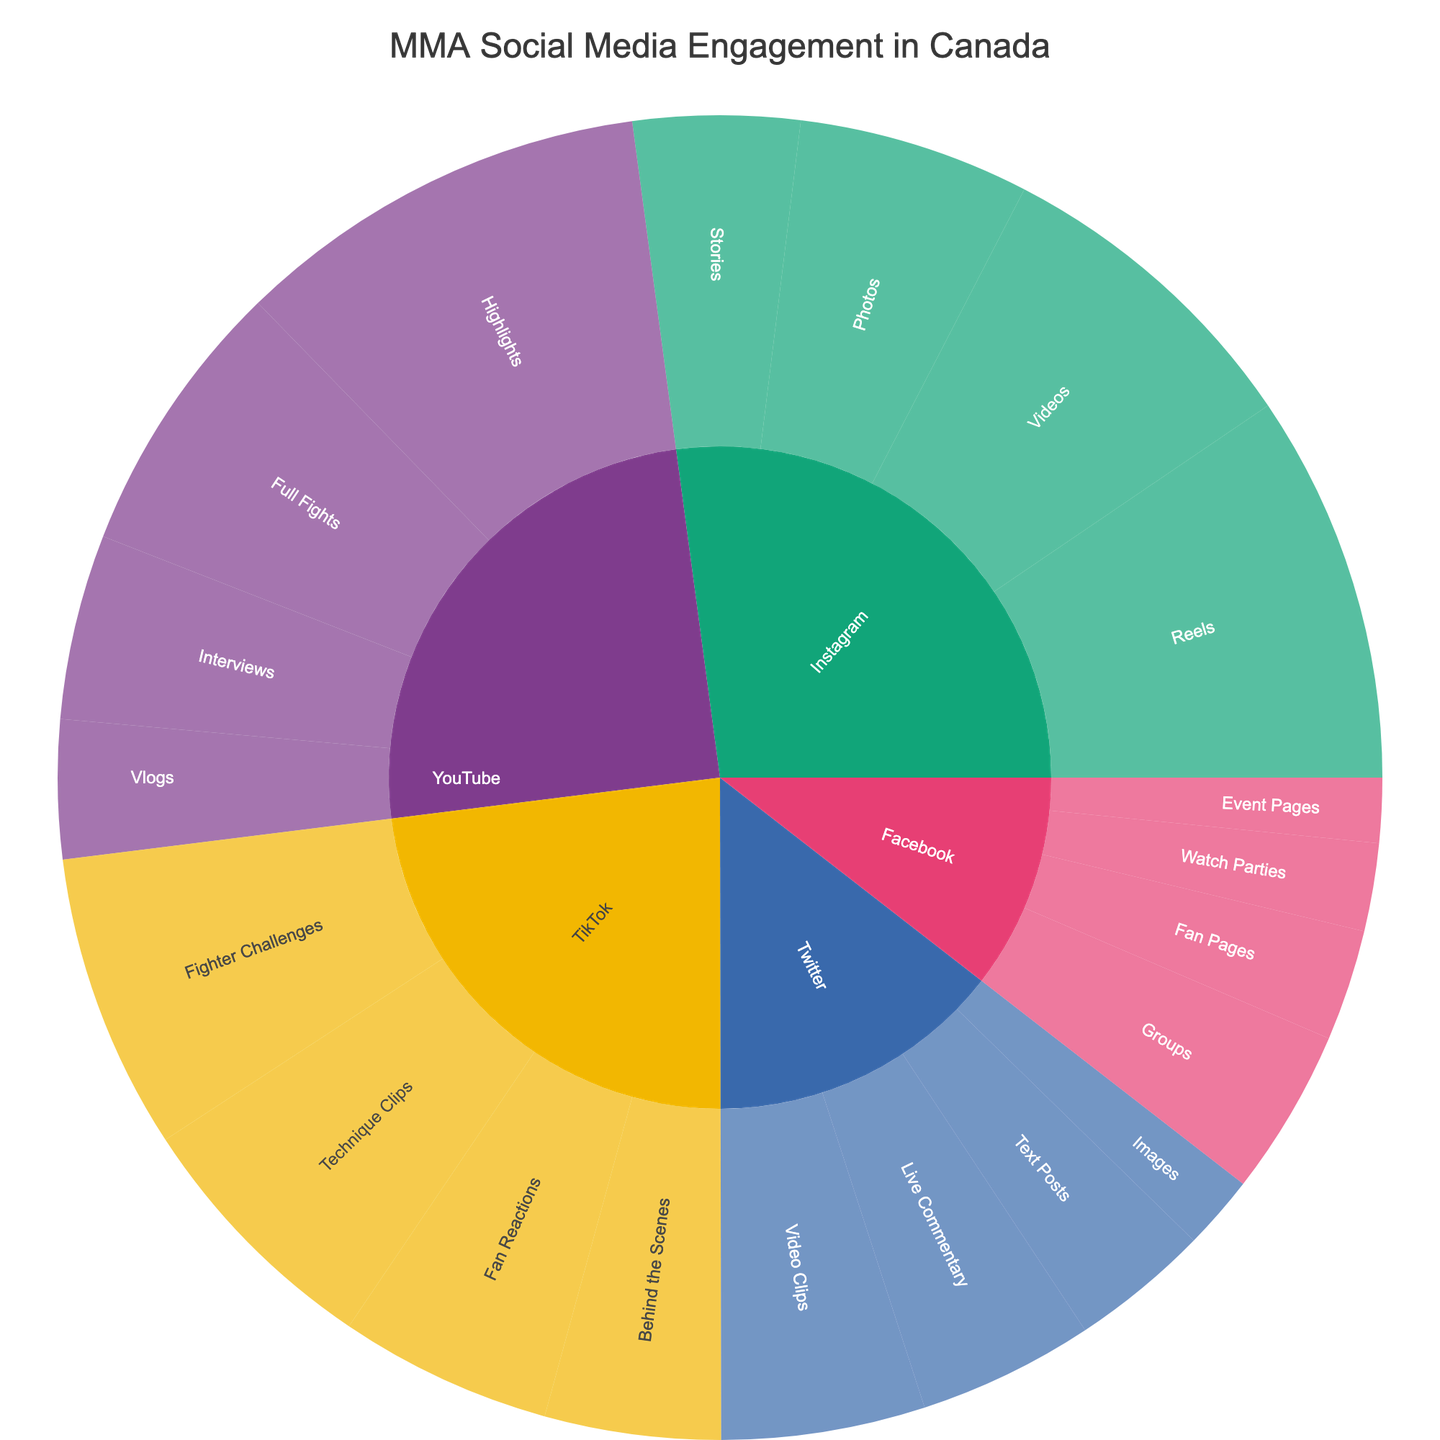What platform generates the most engagement? By looking at the Sunburst Plot, we observe the largest section out of all the platforms. Instagram shows the highest engagement with larger subdivisions when aggregated.
Answer: Instagram What type of content on YouTube has the highest engagement? By examining the YouTube slice within the plot, we see the largest single segment labeled as "Highlights". This signifies the highest engagement.
Answer: Highlights Compare the engagement of Instagram Stories to Twitter Video Clips. Which has more, and by how much? From the plot, Instagram Stories have 180,000 engagements and Twitter Video Clips have 220,000 engagements. Subtracting these values gives 220,000 - 180,000.
Answer: Twitter Video Clips by 40,000 What’s the total engagement for all TikTok content combined? TikTok has segments for Technique Clips (280,000), Fighter Challenges (320,000), Behind the Scenes (190,000), and Fan Reactions (230,000). Summing these: 280,000 + 320,000 + 190,000 + 230,000 equals 1,020,000.
Answer: 1,020,000 Which type of content is unique to Facebook in this dataset, and what’s its engagement? Inspecting the Facebook section, "Watch Parties" is unique, and its engagement is labeled as 95,000.
Answer: Watch Parties (95,000) Is the engagement for YouTube Interviews higher or lower than YouTube Vlogs? By how much? For YouTube, Interviews show 200,000 engagements while Vlogs show 150,000. The difference is 200,000 - 150,000.
Answer: Higher by 50,000 How does the engagement for Instagram Reels compare to YouTube Highlights? Instagram Reels have 420,000 engagements while YouTube Highlights have 450,000. Comparing these, YouTube Highlights are greater by 450,000 - 420,000.
Answer: YouTube Highlights by 30,000 Does Twitter Live Commentary have higher or lower engagement than Facebook Fan Pages? Twitter Live Commentary has an engagement of 190,000 and Facebook Fan Pages have 120,000. Comparing them, Live Commentary is higher.
Answer: Higher What is the average engagement for all Facebook content? Facebook has Fan Pages (120,000), Event Pages (70,000), Watch Parties (95,000), and Groups (180,000). Summing these up: 120,000 + 70,000 + 95,000 + 180,000 = 465,000. Dividing by 4 (the number of content types): 465,000 / 4.
Answer: 116,250 Which platform has the least variance in engagement among its content types? Observing the segments for each platform, the variance is smallest where the segment sizes are most similar. Facebook's segments are the most equally distributed.
Answer: Facebook 